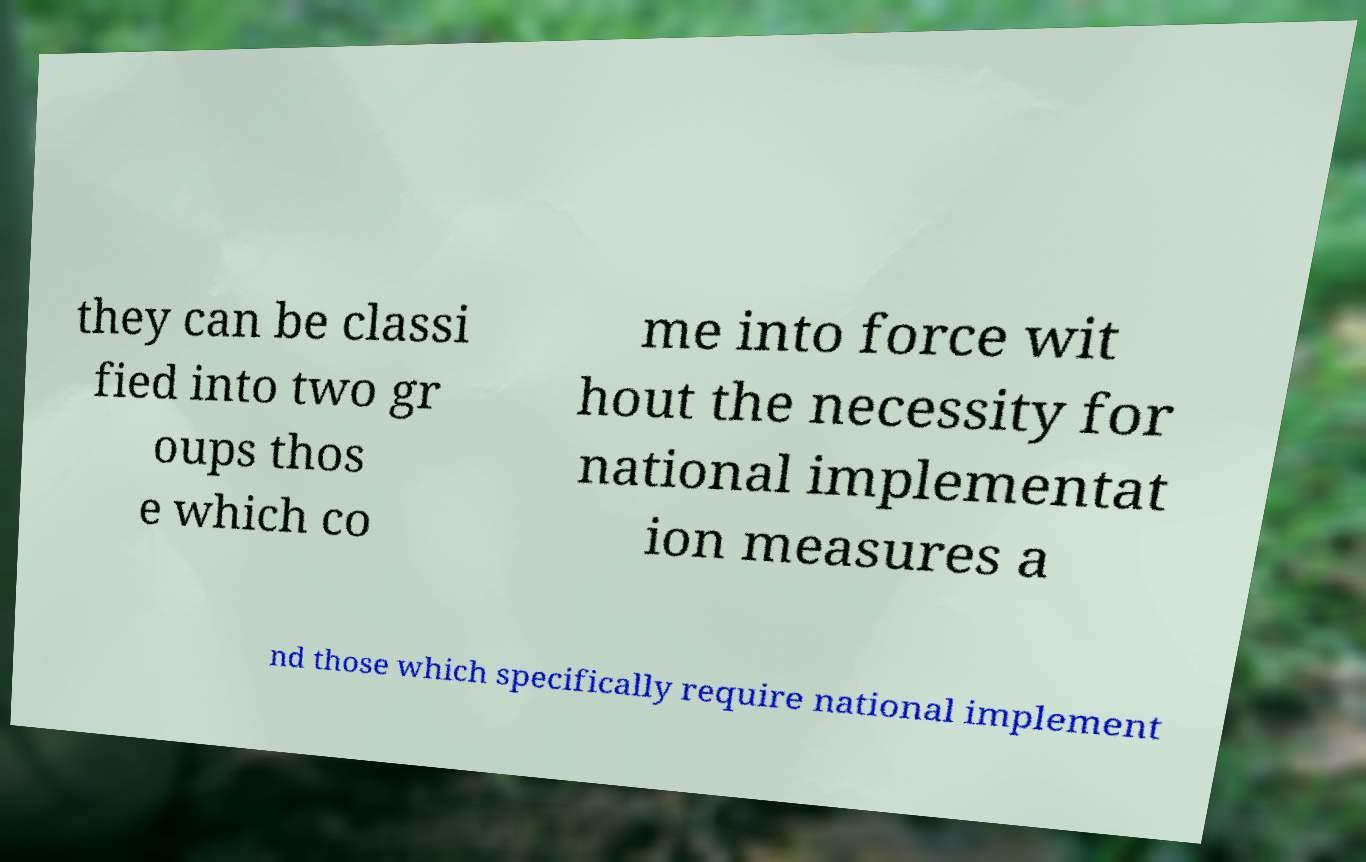Can you read and provide the text displayed in the image?This photo seems to have some interesting text. Can you extract and type it out for me? they can be classi fied into two gr oups thos e which co me into force wit hout the necessity for national implementat ion measures a nd those which specifically require national implement 